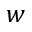<formula> <loc_0><loc_0><loc_500><loc_500>w</formula> 